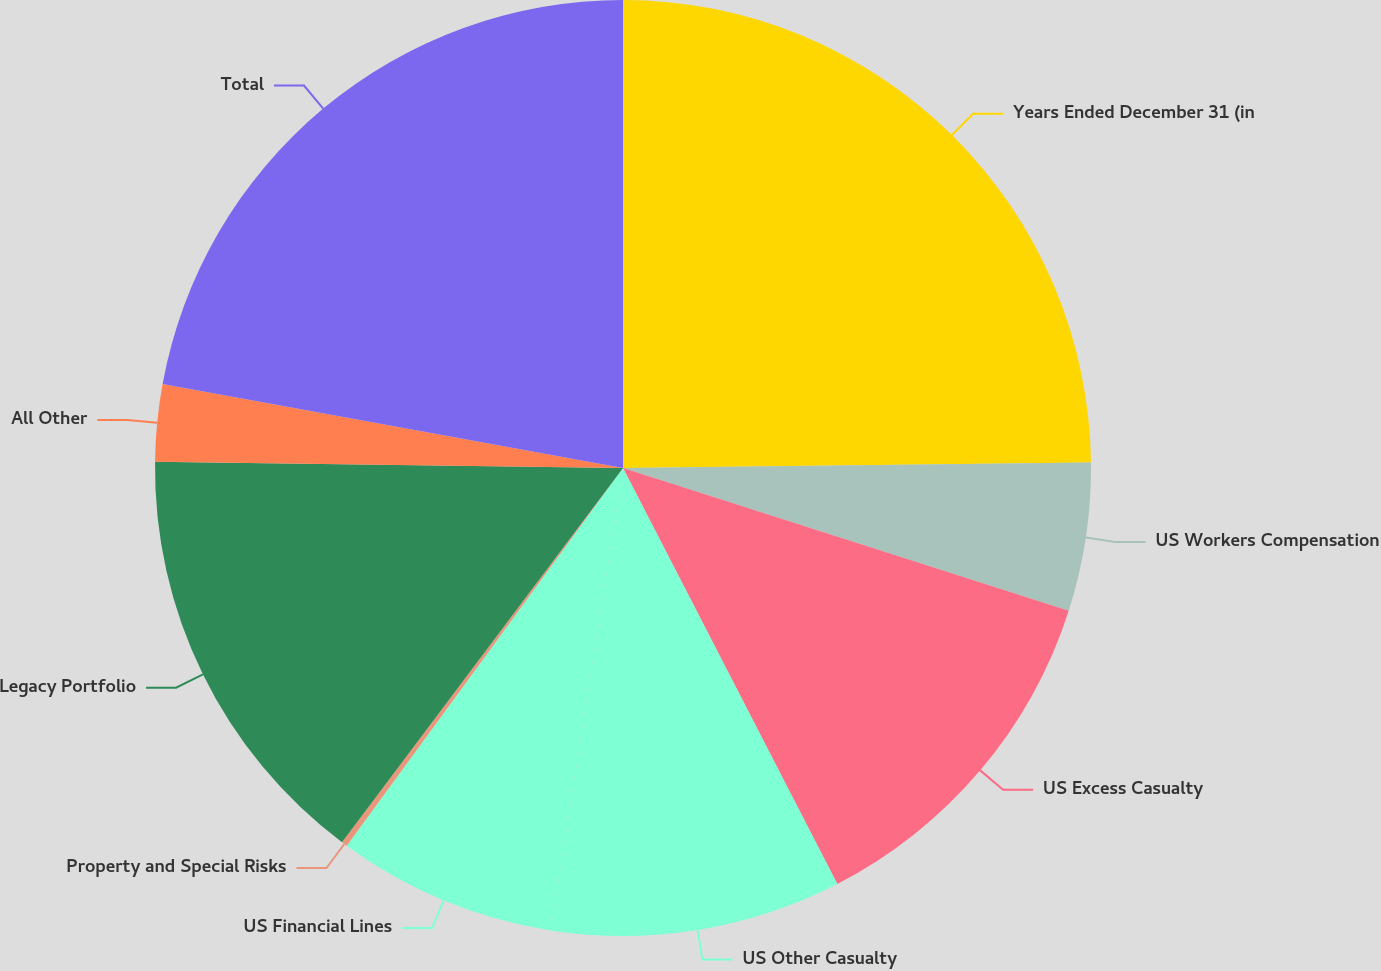Convert chart. <chart><loc_0><loc_0><loc_500><loc_500><pie_chart><fcel>Years Ended December 31 (in<fcel>US Workers Compensation<fcel>US Excess Casualty<fcel>US Other Casualty<fcel>US Financial Lines<fcel>Property and Special Risks<fcel>Legacy Portfolio<fcel>All Other<fcel>Total<nl><fcel>24.81%<fcel>5.12%<fcel>12.5%<fcel>10.04%<fcel>7.58%<fcel>0.2%<fcel>14.96%<fcel>2.66%<fcel>22.13%<nl></chart> 